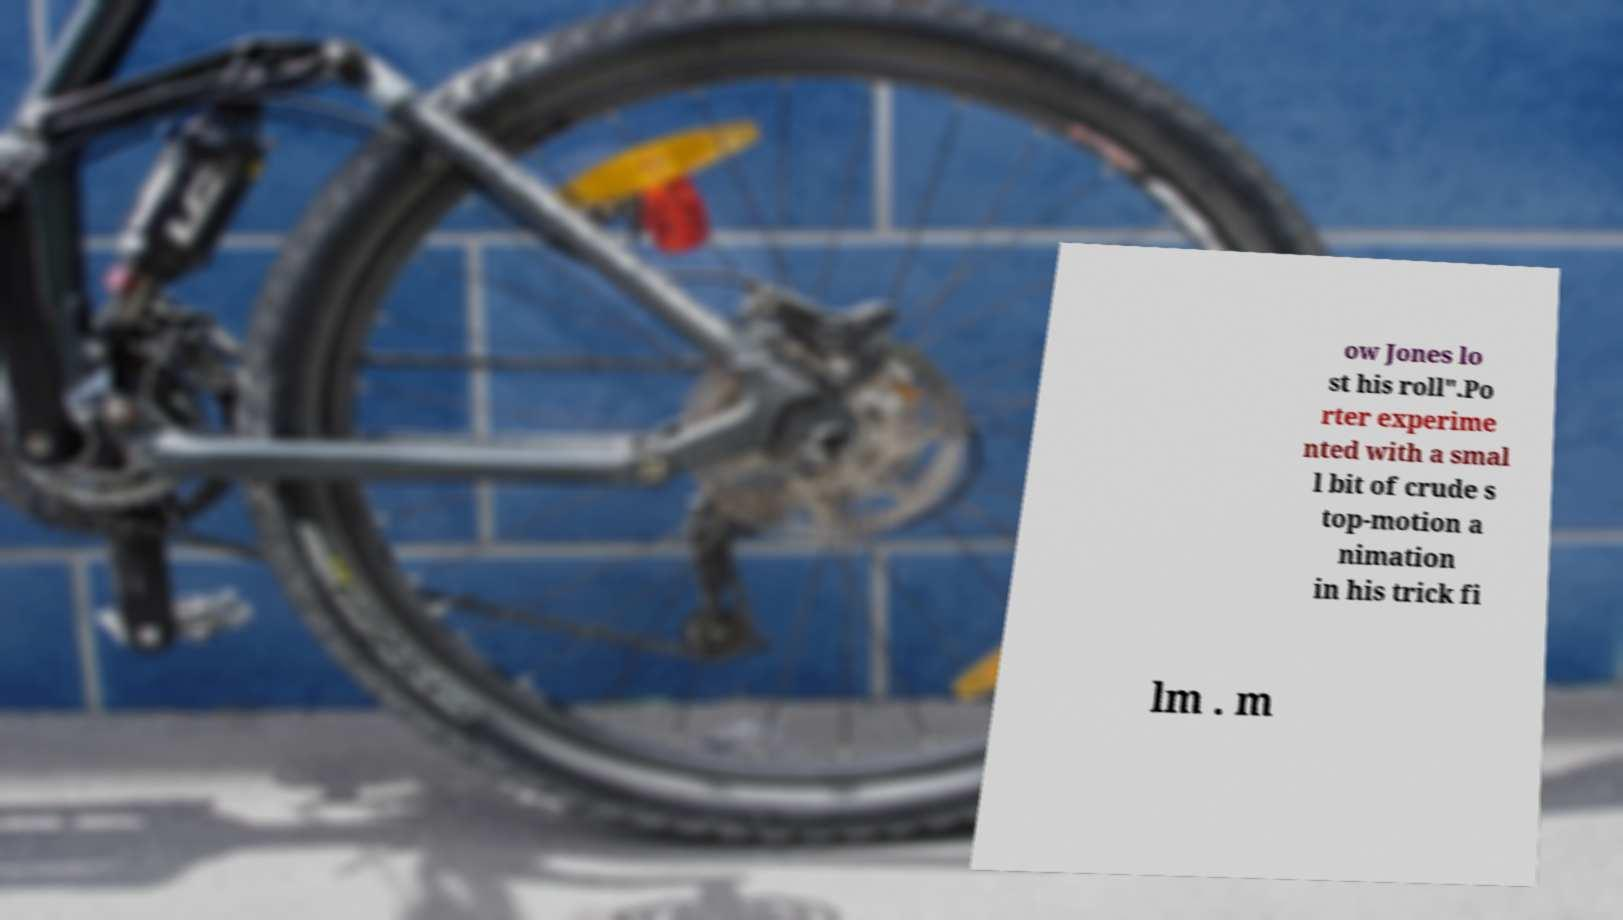Can you accurately transcribe the text from the provided image for me? ow Jones lo st his roll".Po rter experime nted with a smal l bit of crude s top-motion a nimation in his trick fi lm . m 